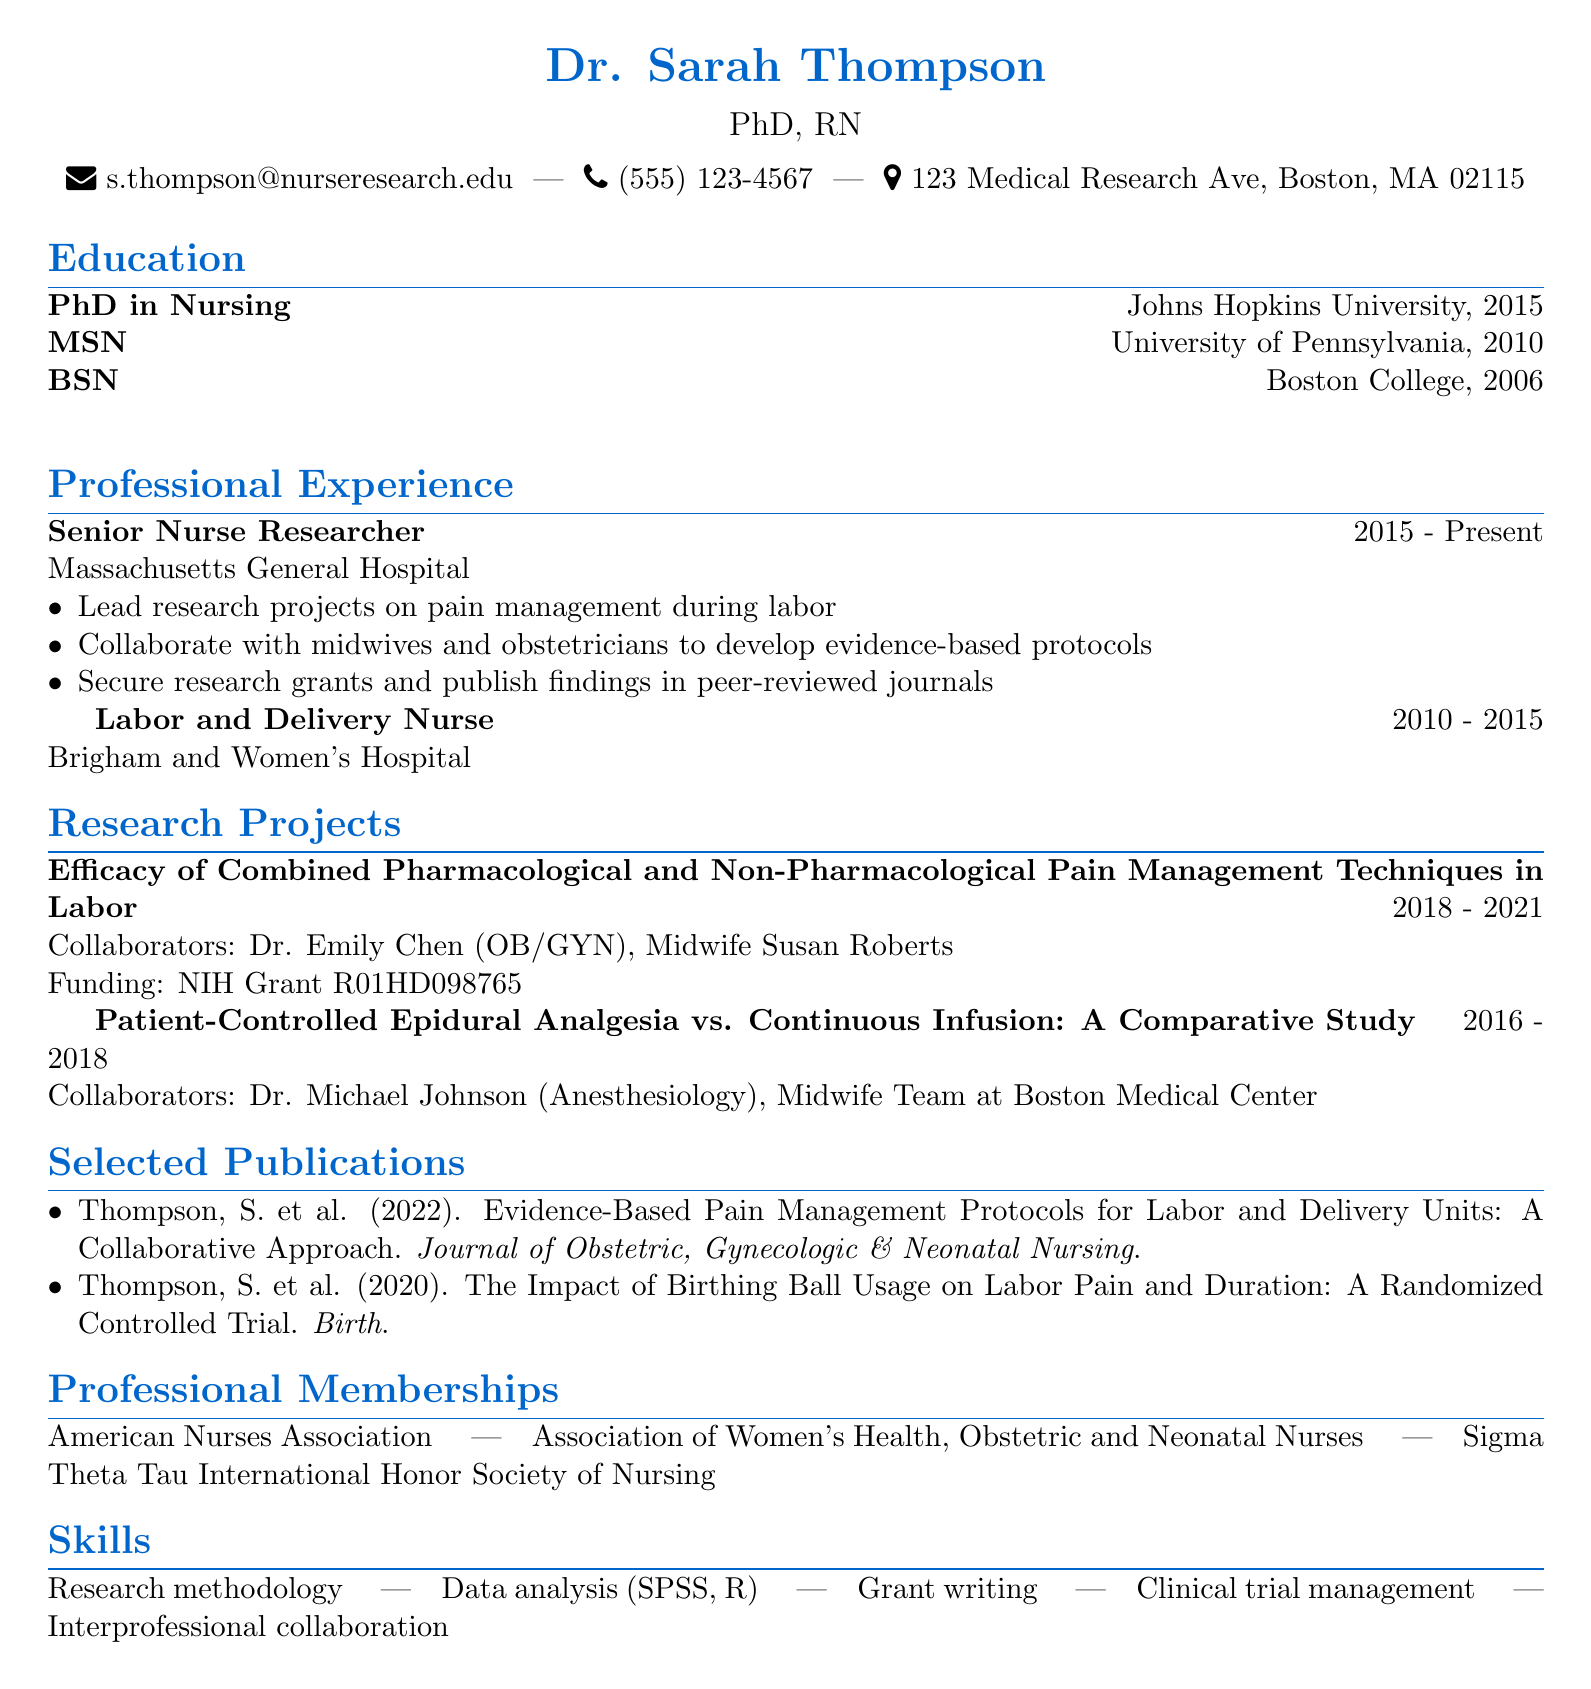What is Dr. Sarah Thompson's title? Dr. Sarah Thompson's title is listed as "PhD, RN".
Answer: PhD, RN Where did Dr. Thompson earn her PhD? The document states that Dr. Thompson earned her PhD from Johns Hopkins University.
Answer: Johns Hopkins University What years did Dr. Thompson work as a Labor and Delivery Nurse? The duration of Dr. Thompson's position as a Labor and Delivery Nurse is provided in the document.
Answer: 2010 - 2015 Who are the collaborators on the research project about pharmacological and non-pharmacological techniques? The document lists Dr. Emily Chen and Midwife Susan Roberts as collaborators for that project.
Answer: Dr. Emily Chen, Midwife Susan Roberts How many publications are listed in the CV? The CV lists two publications authored by Dr. Thompson.
Answer: 2 What type of grants has Dr. Thompson secured? Dr. Thompson has secured research grants, as specified in her professional responsibilities.
Answer: Research grants What is one skill listed under Dr. Thompson's skills section? The CV highlights multiple skills; one notable skill mentioned is data analysis.
Answer: Data analysis What is the title of Dr. Thompson's most recent publication? The most recent publication listed in the document discusses evidence-based pain management protocols.
Answer: Evidence-Based Pain Management Protocols for Labor and Delivery Units: A Collaborative Approach Which organization is Dr. Thompson a member of? The document lists several professional memberships, one of which is the American Nurses Association.
Answer: American Nurses Association 